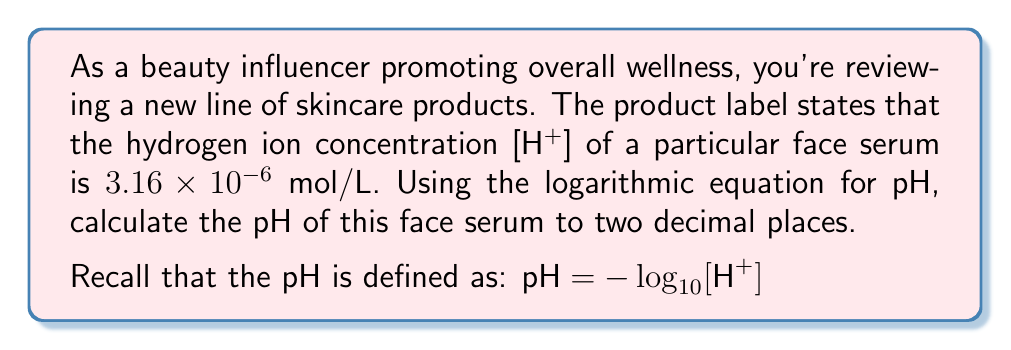Solve this math problem. To solve this problem, we'll use the given logarithmic equation for pH and the hydrogen ion concentration:

1) The equation for pH is:
   $pH = -\log_{10}[H^+]$

2) We're given that $[H^+] = 3.16 \times 10^{-6}$ mol/L

3) Let's substitute this into our equation:
   $pH = -\log_{10}(3.16 \times 10^{-6})$

4) Now, we can use the properties of logarithms to simplify this:
   $pH = -(\log_{10}(3.16) + \log_{10}(10^{-6}))$

5) We know that $\log_{10}(10^{-6}) = -6$, so:
   $pH = -(0.4997 - 6)$

6) Simplifying:
   $pH = -0.4997 + 6 = 5.5003$

7) Rounding to two decimal places:
   $pH = 5.50$

This pH level indicates that the face serum is slightly acidic, which is typical for many skincare products as it helps maintain the skin's natural acid mantle.
Answer: $5.50$ 